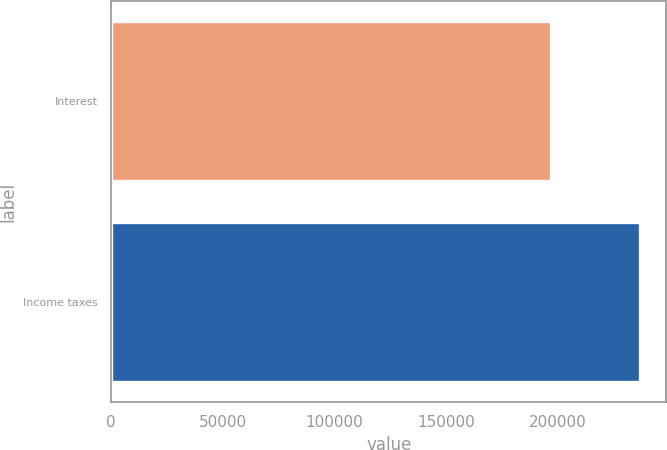Convert chart. <chart><loc_0><loc_0><loc_500><loc_500><bar_chart><fcel>Interest<fcel>Income taxes<nl><fcel>197161<fcel>236972<nl></chart> 